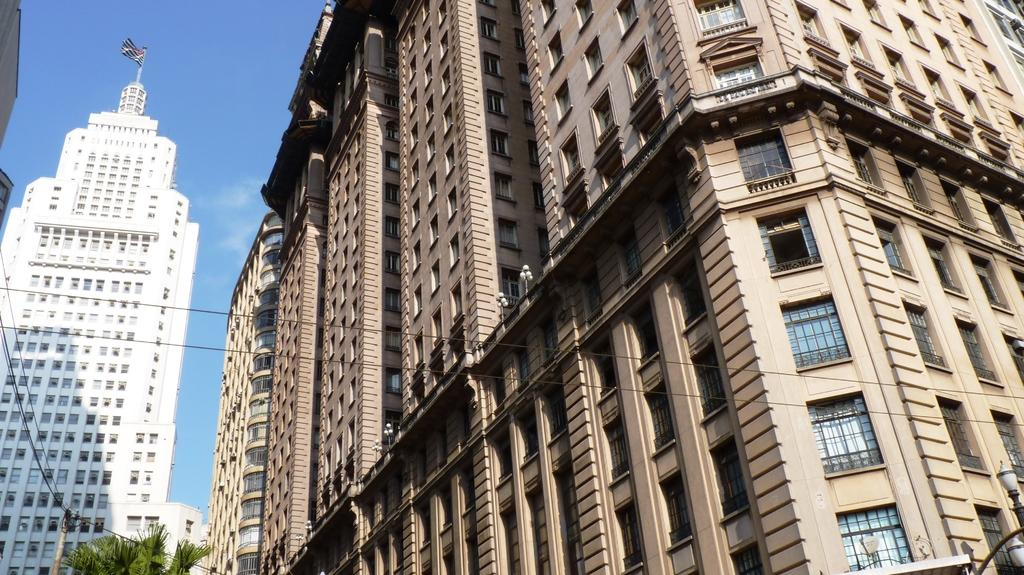What type of structures are located on the right side of the image? There are big buildings on the right side of the image. What can be seen on the left side of the image? There is a building in white color on the left side of the image. What is visible at the top of the image? The sky is visible at the top of the image. Where is the goat in the image? There is no goat present in the image. What type of animals can be seen at the zoo in the image? There is no zoo present in the image. 